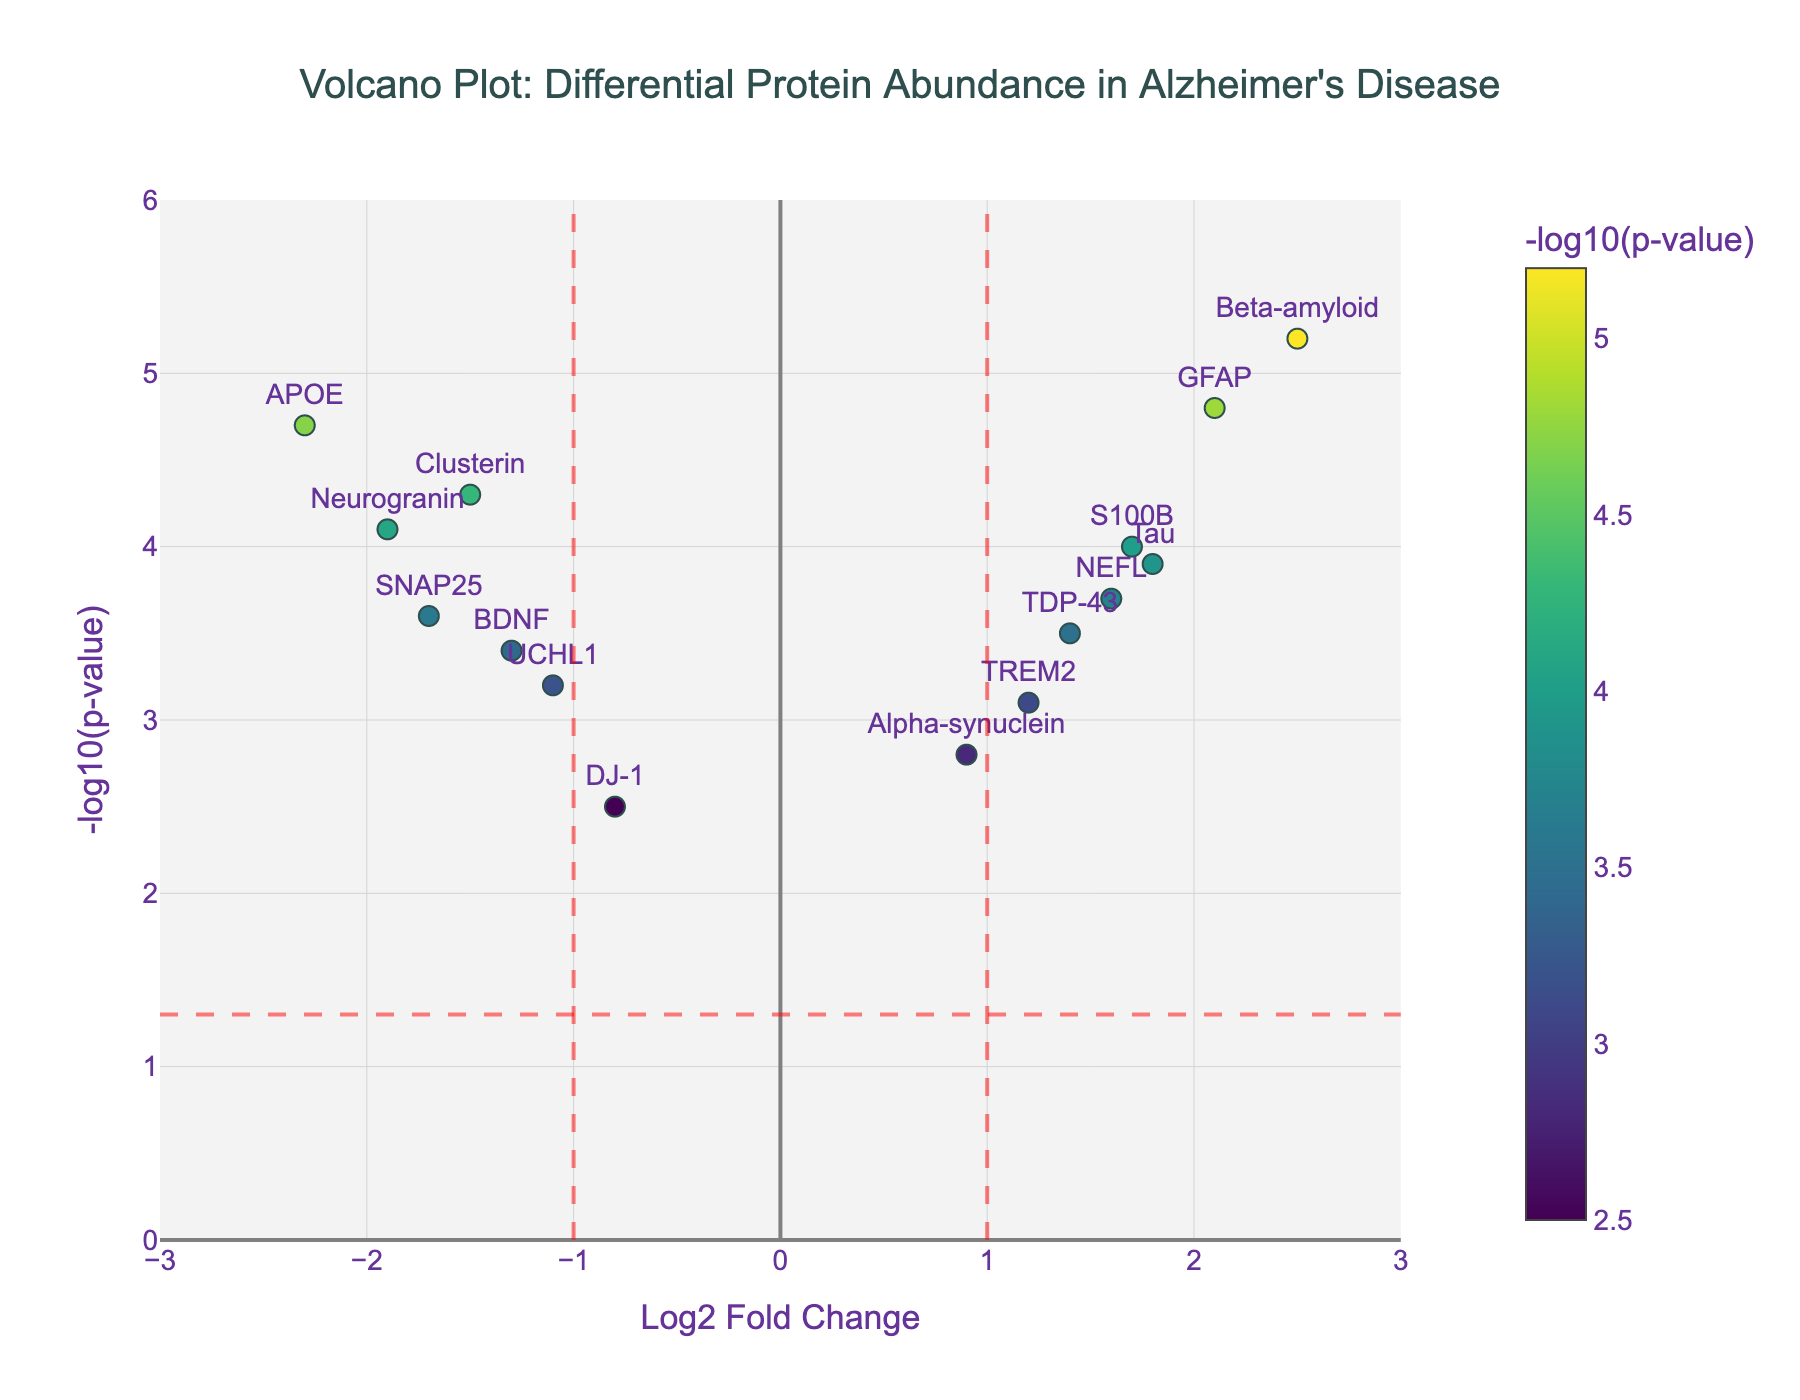What is the title of the plot? The title is displayed at the top of the plot and reads "Volcano Plot: Differential Protein Abundance in Alzheimer's Disease."
Answer: Volcano Plot: Differential Protein Abundance in Alzheimer's Disease How many proteins have their names displayed on the plot? The plot displays the names of the proteins directly above or beside the data points. Counting them can give us the answer. There are 15 proteins displayed.
Answer: 15 Which protein has the highest -log10(p-value) and what is the value? By looking at the y-axis, the protein with the highest -log10(p-value) is Beta-amyloid, which appears at 5.2.
Answer: Beta-amyloid, 5.2 Which protein has the most negative Log2 Fold Change? On the x-axis, the protein with the most negative Log2 Fold Change is APOE, at -2.3.
Answer: APOE Are there any proteins with a Log2 Fold Change between -1 and 1? If so, name them. Examine the range between -1 and 1 on the x-axis, and identify the proteins within this range. Alpha-synuclein and DJ-1 fall within this range.
Answer: Alpha-synuclein, DJ-1 Which proteins are considered significant based on the given thresholds? Significant proteins need to have a -log10(p-value) value greater than 1.3 (corresponding to p-value < 0.05) and an absolute Log2 Fold Change greater than 1. These proteins are Beta-amyloid, APOE, GFAP, and Tau.
Answer: Beta-amyloid, APOE, GFAP, Tau How many proteins have a -log10(p-value) greater than 3.5 and a positive Log2 Fold Change? Count the proteins that lie above 3.5 on the y-axis and have a positive x-axis value. There are four such proteins: Tau, Beta-amyloid, GFAP, and S100B.
Answer: 4 Which protein has a similar -log10(p-value) to Clusterin but a positive Log2 Fold Change? Clusterin has a -log10(p-value) of 4.3 with a negative Log2 Fold Change. S100B has a -log10(p-value) of approximately 4.0 and a positive Log2 Fold Change, making it quite similar.
Answer: S100B Is there a protein with both a high -log10(p-value) and a high positive Log2 Fold Change? A high value can be considered anything above thresholds. Beta-amyloid has both a high -log10(p-value) of 5.2 and a high positive Log2 Fold Change of 2.5.
Answer: Beta-amyloid 